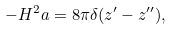<formula> <loc_0><loc_0><loc_500><loc_500>- H ^ { 2 } a = 8 \pi \delta ( z ^ { \prime } - z ^ { \prime \prime } ) ,</formula> 